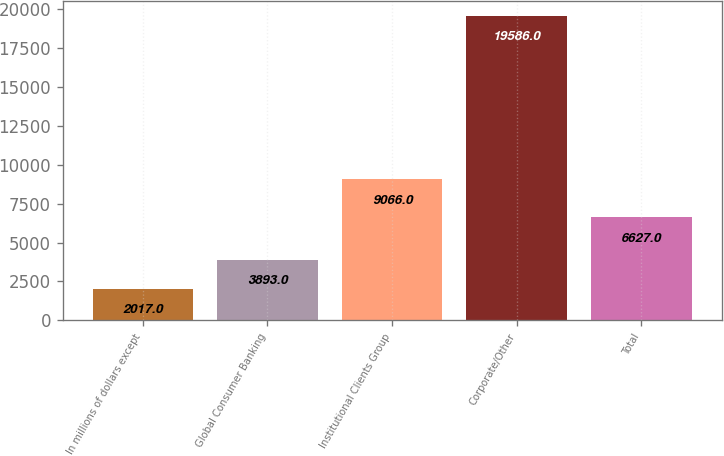<chart> <loc_0><loc_0><loc_500><loc_500><bar_chart><fcel>In millions of dollars except<fcel>Global Consumer Banking<fcel>Institutional Clients Group<fcel>Corporate/Other<fcel>Total<nl><fcel>2017<fcel>3893<fcel>9066<fcel>19586<fcel>6627<nl></chart> 